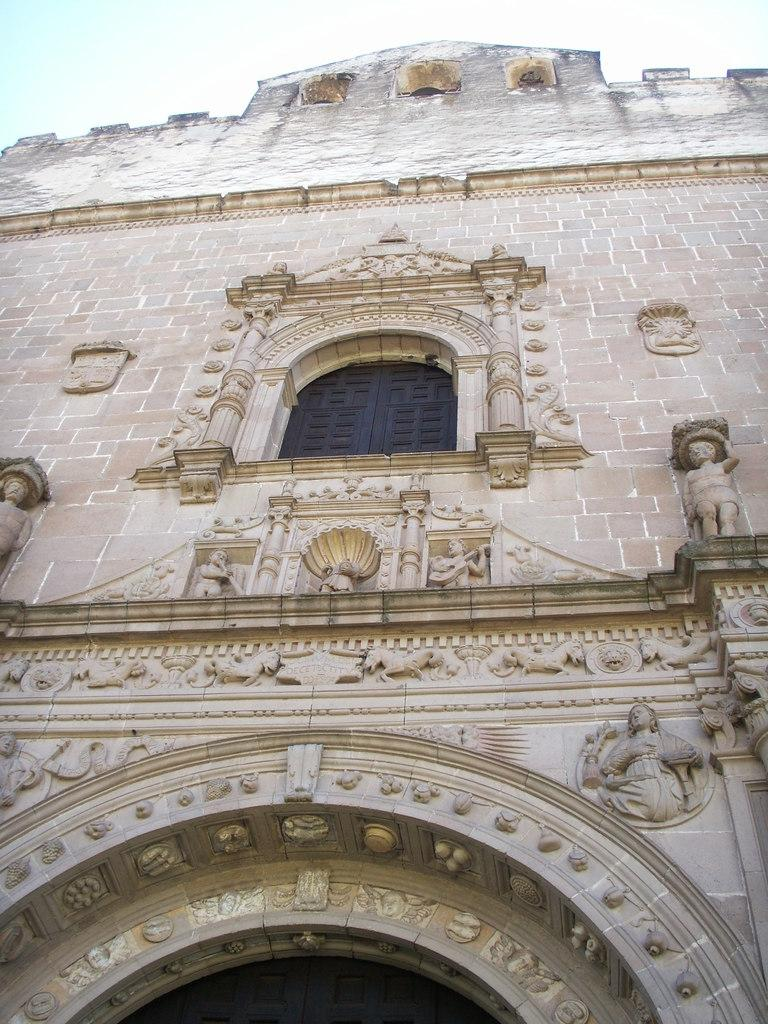What type of structure is present in the image? There is a building in the image. Can you describe any specific features of the building? There is a window in the building. What other objects or figures can be seen in the image? There are statues visible in the image. What can be seen in the background of the image? The sky is visible in the background of the image. What type of cake is being served to the dogs in the image? There are no dogs or cake present in the image; it features a building with a window and statues. 